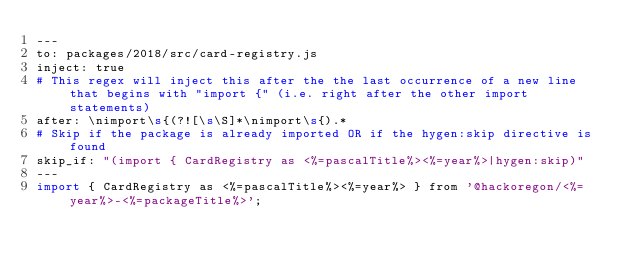Convert code to text. <code><loc_0><loc_0><loc_500><loc_500><_Perl_>---
to: packages/2018/src/card-registry.js
inject: true
# This regex will inject this after the the last occurrence of a new line that begins with "import {" (i.e. right after the other import statements)
after: \nimport\s{(?![\s\S]*\nimport\s{).*
# Skip if the package is already imported OR if the hygen:skip directive is found
skip_if: "(import { CardRegistry as <%=pascalTitle%><%=year%>|hygen:skip)"
---
import { CardRegistry as <%=pascalTitle%><%=year%> } from '@hackoregon/<%=year%>-<%=packageTitle%>';
</code> 